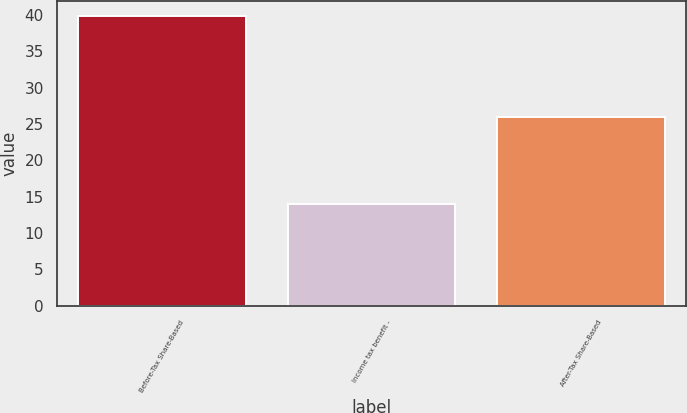<chart> <loc_0><loc_0><loc_500><loc_500><bar_chart><fcel>Before-Tax Share-Based<fcel>Income tax benefit -<fcel>After-Tax Share-Based<nl><fcel>39.9<fcel>14<fcel>25.9<nl></chart> 